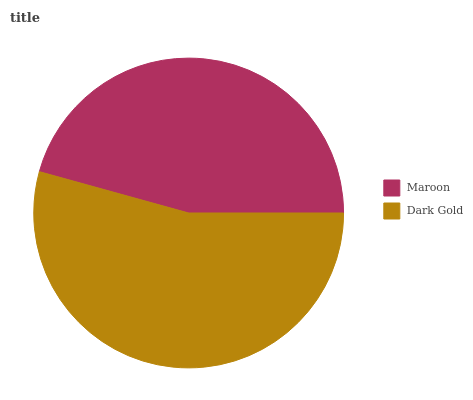Is Maroon the minimum?
Answer yes or no. Yes. Is Dark Gold the maximum?
Answer yes or no. Yes. Is Dark Gold the minimum?
Answer yes or no. No. Is Dark Gold greater than Maroon?
Answer yes or no. Yes. Is Maroon less than Dark Gold?
Answer yes or no. Yes. Is Maroon greater than Dark Gold?
Answer yes or no. No. Is Dark Gold less than Maroon?
Answer yes or no. No. Is Dark Gold the high median?
Answer yes or no. Yes. Is Maroon the low median?
Answer yes or no. Yes. Is Maroon the high median?
Answer yes or no. No. Is Dark Gold the low median?
Answer yes or no. No. 